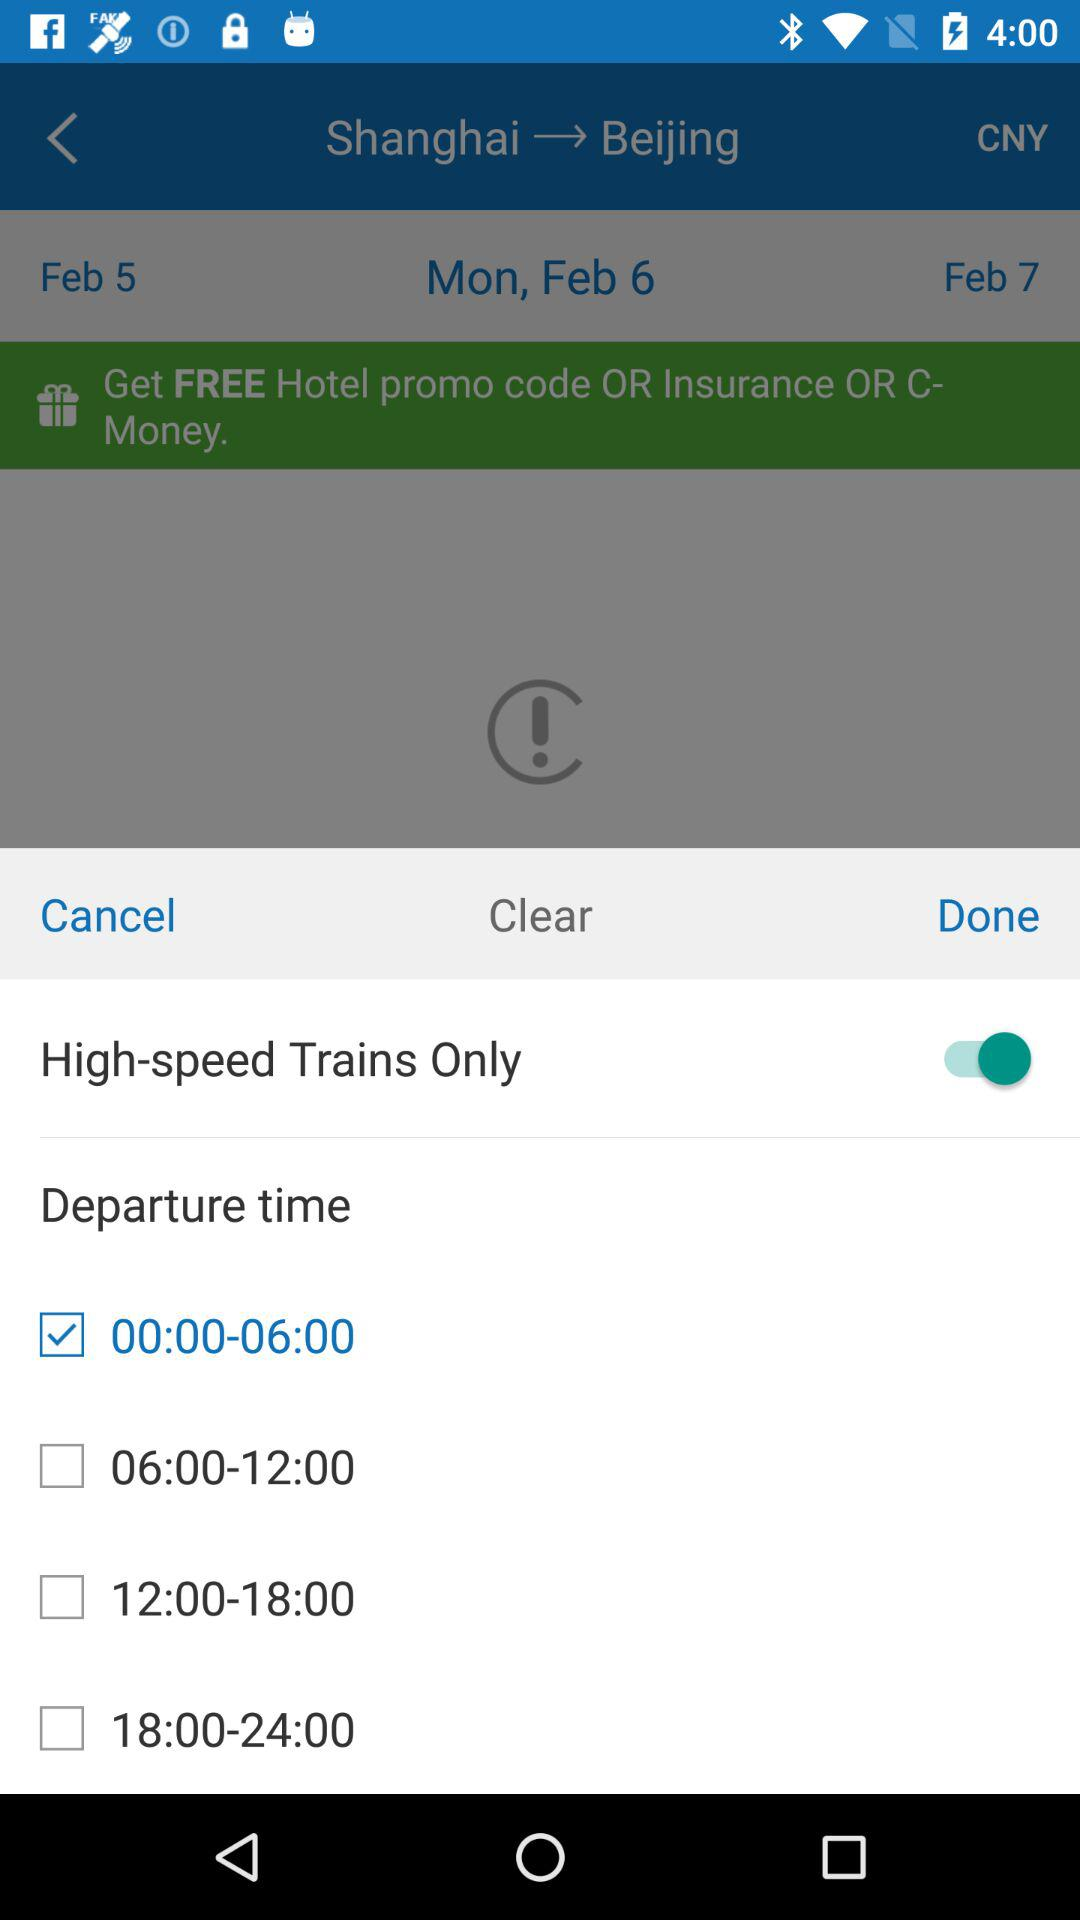How many days are available for selection?
Answer the question using a single word or phrase. 3 